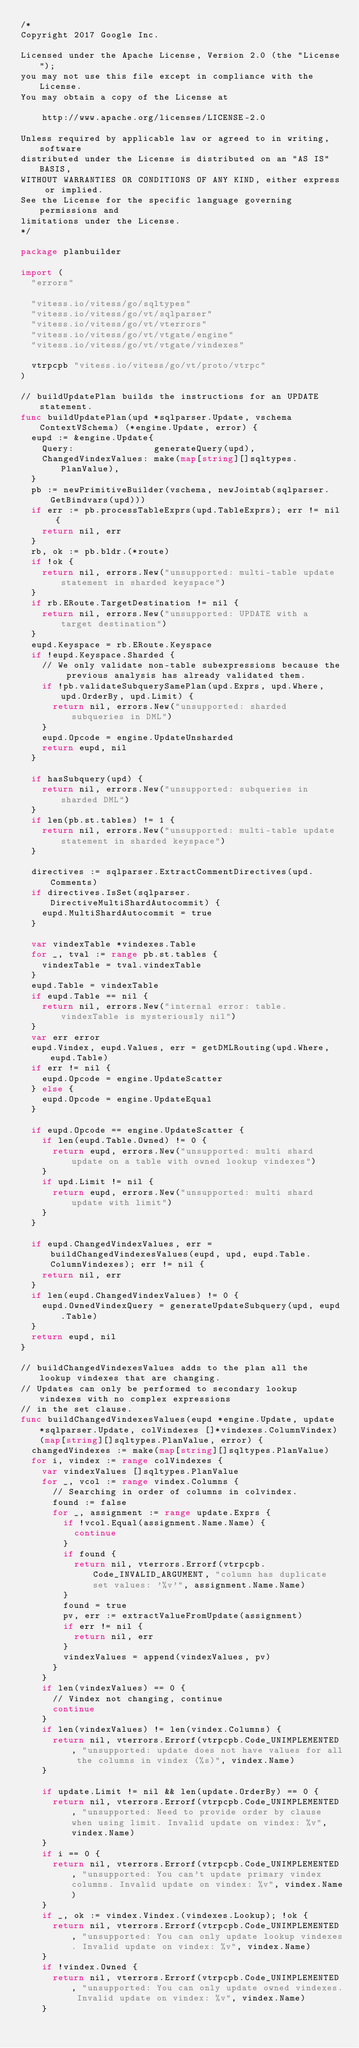<code> <loc_0><loc_0><loc_500><loc_500><_Go_>/*
Copyright 2017 Google Inc.

Licensed under the Apache License, Version 2.0 (the "License");
you may not use this file except in compliance with the License.
You may obtain a copy of the License at

    http://www.apache.org/licenses/LICENSE-2.0

Unless required by applicable law or agreed to in writing, software
distributed under the License is distributed on an "AS IS" BASIS,
WITHOUT WARRANTIES OR CONDITIONS OF ANY KIND, either express or implied.
See the License for the specific language governing permissions and
limitations under the License.
*/

package planbuilder

import (
	"errors"

	"vitess.io/vitess/go/sqltypes"
	"vitess.io/vitess/go/vt/sqlparser"
	"vitess.io/vitess/go/vt/vterrors"
	"vitess.io/vitess/go/vt/vtgate/engine"
	"vitess.io/vitess/go/vt/vtgate/vindexes"

	vtrpcpb "vitess.io/vitess/go/vt/proto/vtrpc"
)

// buildUpdatePlan builds the instructions for an UPDATE statement.
func buildUpdatePlan(upd *sqlparser.Update, vschema ContextVSchema) (*engine.Update, error) {
	eupd := &engine.Update{
		Query:               generateQuery(upd),
		ChangedVindexValues: make(map[string][]sqltypes.PlanValue),
	}
	pb := newPrimitiveBuilder(vschema, newJointab(sqlparser.GetBindvars(upd)))
	if err := pb.processTableExprs(upd.TableExprs); err != nil {
		return nil, err
	}
	rb, ok := pb.bldr.(*route)
	if !ok {
		return nil, errors.New("unsupported: multi-table update statement in sharded keyspace")
	}
	if rb.ERoute.TargetDestination != nil {
		return nil, errors.New("unsupported: UPDATE with a target destination")
	}
	eupd.Keyspace = rb.ERoute.Keyspace
	if !eupd.Keyspace.Sharded {
		// We only validate non-table subexpressions because the previous analysis has already validated them.
		if !pb.validateSubquerySamePlan(upd.Exprs, upd.Where, upd.OrderBy, upd.Limit) {
			return nil, errors.New("unsupported: sharded subqueries in DML")
		}
		eupd.Opcode = engine.UpdateUnsharded
		return eupd, nil
	}

	if hasSubquery(upd) {
		return nil, errors.New("unsupported: subqueries in sharded DML")
	}
	if len(pb.st.tables) != 1 {
		return nil, errors.New("unsupported: multi-table update statement in sharded keyspace")
	}

	directives := sqlparser.ExtractCommentDirectives(upd.Comments)
	if directives.IsSet(sqlparser.DirectiveMultiShardAutocommit) {
		eupd.MultiShardAutocommit = true
	}

	var vindexTable *vindexes.Table
	for _, tval := range pb.st.tables {
		vindexTable = tval.vindexTable
	}
	eupd.Table = vindexTable
	if eupd.Table == nil {
		return nil, errors.New("internal error: table.vindexTable is mysteriously nil")
	}
	var err error
	eupd.Vindex, eupd.Values, err = getDMLRouting(upd.Where, eupd.Table)
	if err != nil {
		eupd.Opcode = engine.UpdateScatter
	} else {
		eupd.Opcode = engine.UpdateEqual
	}

	if eupd.Opcode == engine.UpdateScatter {
		if len(eupd.Table.Owned) != 0 {
			return eupd, errors.New("unsupported: multi shard update on a table with owned lookup vindexes")
		}
		if upd.Limit != nil {
			return eupd, errors.New("unsupported: multi shard update with limit")
		}
	}

	if eupd.ChangedVindexValues, err = buildChangedVindexesValues(eupd, upd, eupd.Table.ColumnVindexes); err != nil {
		return nil, err
	}
	if len(eupd.ChangedVindexValues) != 0 {
		eupd.OwnedVindexQuery = generateUpdateSubquery(upd, eupd.Table)
	}
	return eupd, nil
}

// buildChangedVindexesValues adds to the plan all the lookup vindexes that are changing.
// Updates can only be performed to secondary lookup vindexes with no complex expressions
// in the set clause.
func buildChangedVindexesValues(eupd *engine.Update, update *sqlparser.Update, colVindexes []*vindexes.ColumnVindex) (map[string][]sqltypes.PlanValue, error) {
	changedVindexes := make(map[string][]sqltypes.PlanValue)
	for i, vindex := range colVindexes {
		var vindexValues []sqltypes.PlanValue
		for _, vcol := range vindex.Columns {
			// Searching in order of columns in colvindex.
			found := false
			for _, assignment := range update.Exprs {
				if !vcol.Equal(assignment.Name.Name) {
					continue
				}
				if found {
					return nil, vterrors.Errorf(vtrpcpb.Code_INVALID_ARGUMENT, "column has duplicate set values: '%v'", assignment.Name.Name)
				}
				found = true
				pv, err := extractValueFromUpdate(assignment)
				if err != nil {
					return nil, err
				}
				vindexValues = append(vindexValues, pv)
			}
		}
		if len(vindexValues) == 0 {
			// Vindex not changing, continue
			continue
		}
		if len(vindexValues) != len(vindex.Columns) {
			return nil, vterrors.Errorf(vtrpcpb.Code_UNIMPLEMENTED, "unsupported: update does not have values for all the columns in vindex (%s)", vindex.Name)
		}

		if update.Limit != nil && len(update.OrderBy) == 0 {
			return nil, vterrors.Errorf(vtrpcpb.Code_UNIMPLEMENTED, "unsupported: Need to provide order by clause when using limit. Invalid update on vindex: %v", vindex.Name)
		}
		if i == 0 {
			return nil, vterrors.Errorf(vtrpcpb.Code_UNIMPLEMENTED, "unsupported: You can't update primary vindex columns. Invalid update on vindex: %v", vindex.Name)
		}
		if _, ok := vindex.Vindex.(vindexes.Lookup); !ok {
			return nil, vterrors.Errorf(vtrpcpb.Code_UNIMPLEMENTED, "unsupported: You can only update lookup vindexes. Invalid update on vindex: %v", vindex.Name)
		}
		if !vindex.Owned {
			return nil, vterrors.Errorf(vtrpcpb.Code_UNIMPLEMENTED, "unsupported: You can only update owned vindexes. Invalid update on vindex: %v", vindex.Name)
		}</code> 